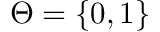<formula> <loc_0><loc_0><loc_500><loc_500>\Theta = \{ 0 , 1 \}</formula> 